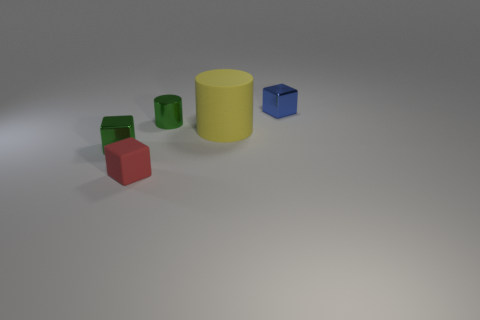What is the green cylinder made of?
Keep it short and to the point. Metal. There is a small cube that is in front of the small metallic cube in front of the tiny metal object behind the tiny cylinder; what is its color?
Give a very brief answer. Red. There is a blue object that is the same shape as the red thing; what is it made of?
Make the answer very short. Metal. How many green shiny blocks are the same size as the green shiny cylinder?
Give a very brief answer. 1. What number of small purple metallic spheres are there?
Make the answer very short. 0. Do the large yellow object and the green object behind the matte cylinder have the same material?
Offer a very short reply. No. How many cyan objects are shiny cubes or rubber things?
Provide a short and direct response. 0. The cylinder that is the same material as the tiny red block is what size?
Your answer should be very brief. Large. What number of other small metallic things have the same shape as the blue thing?
Keep it short and to the point. 1. Is the number of small matte blocks behind the green metallic cylinder greater than the number of small metal cylinders that are to the left of the red rubber object?
Provide a succinct answer. No. 